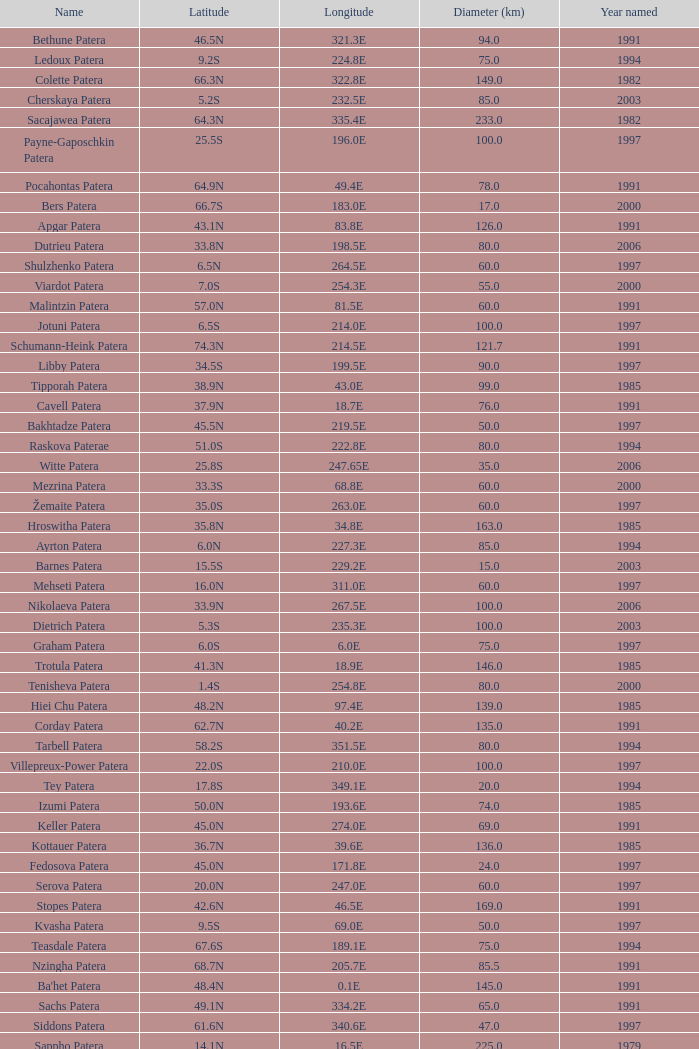What is Year Named, when Longitude is 227.5E? 1997.0. 